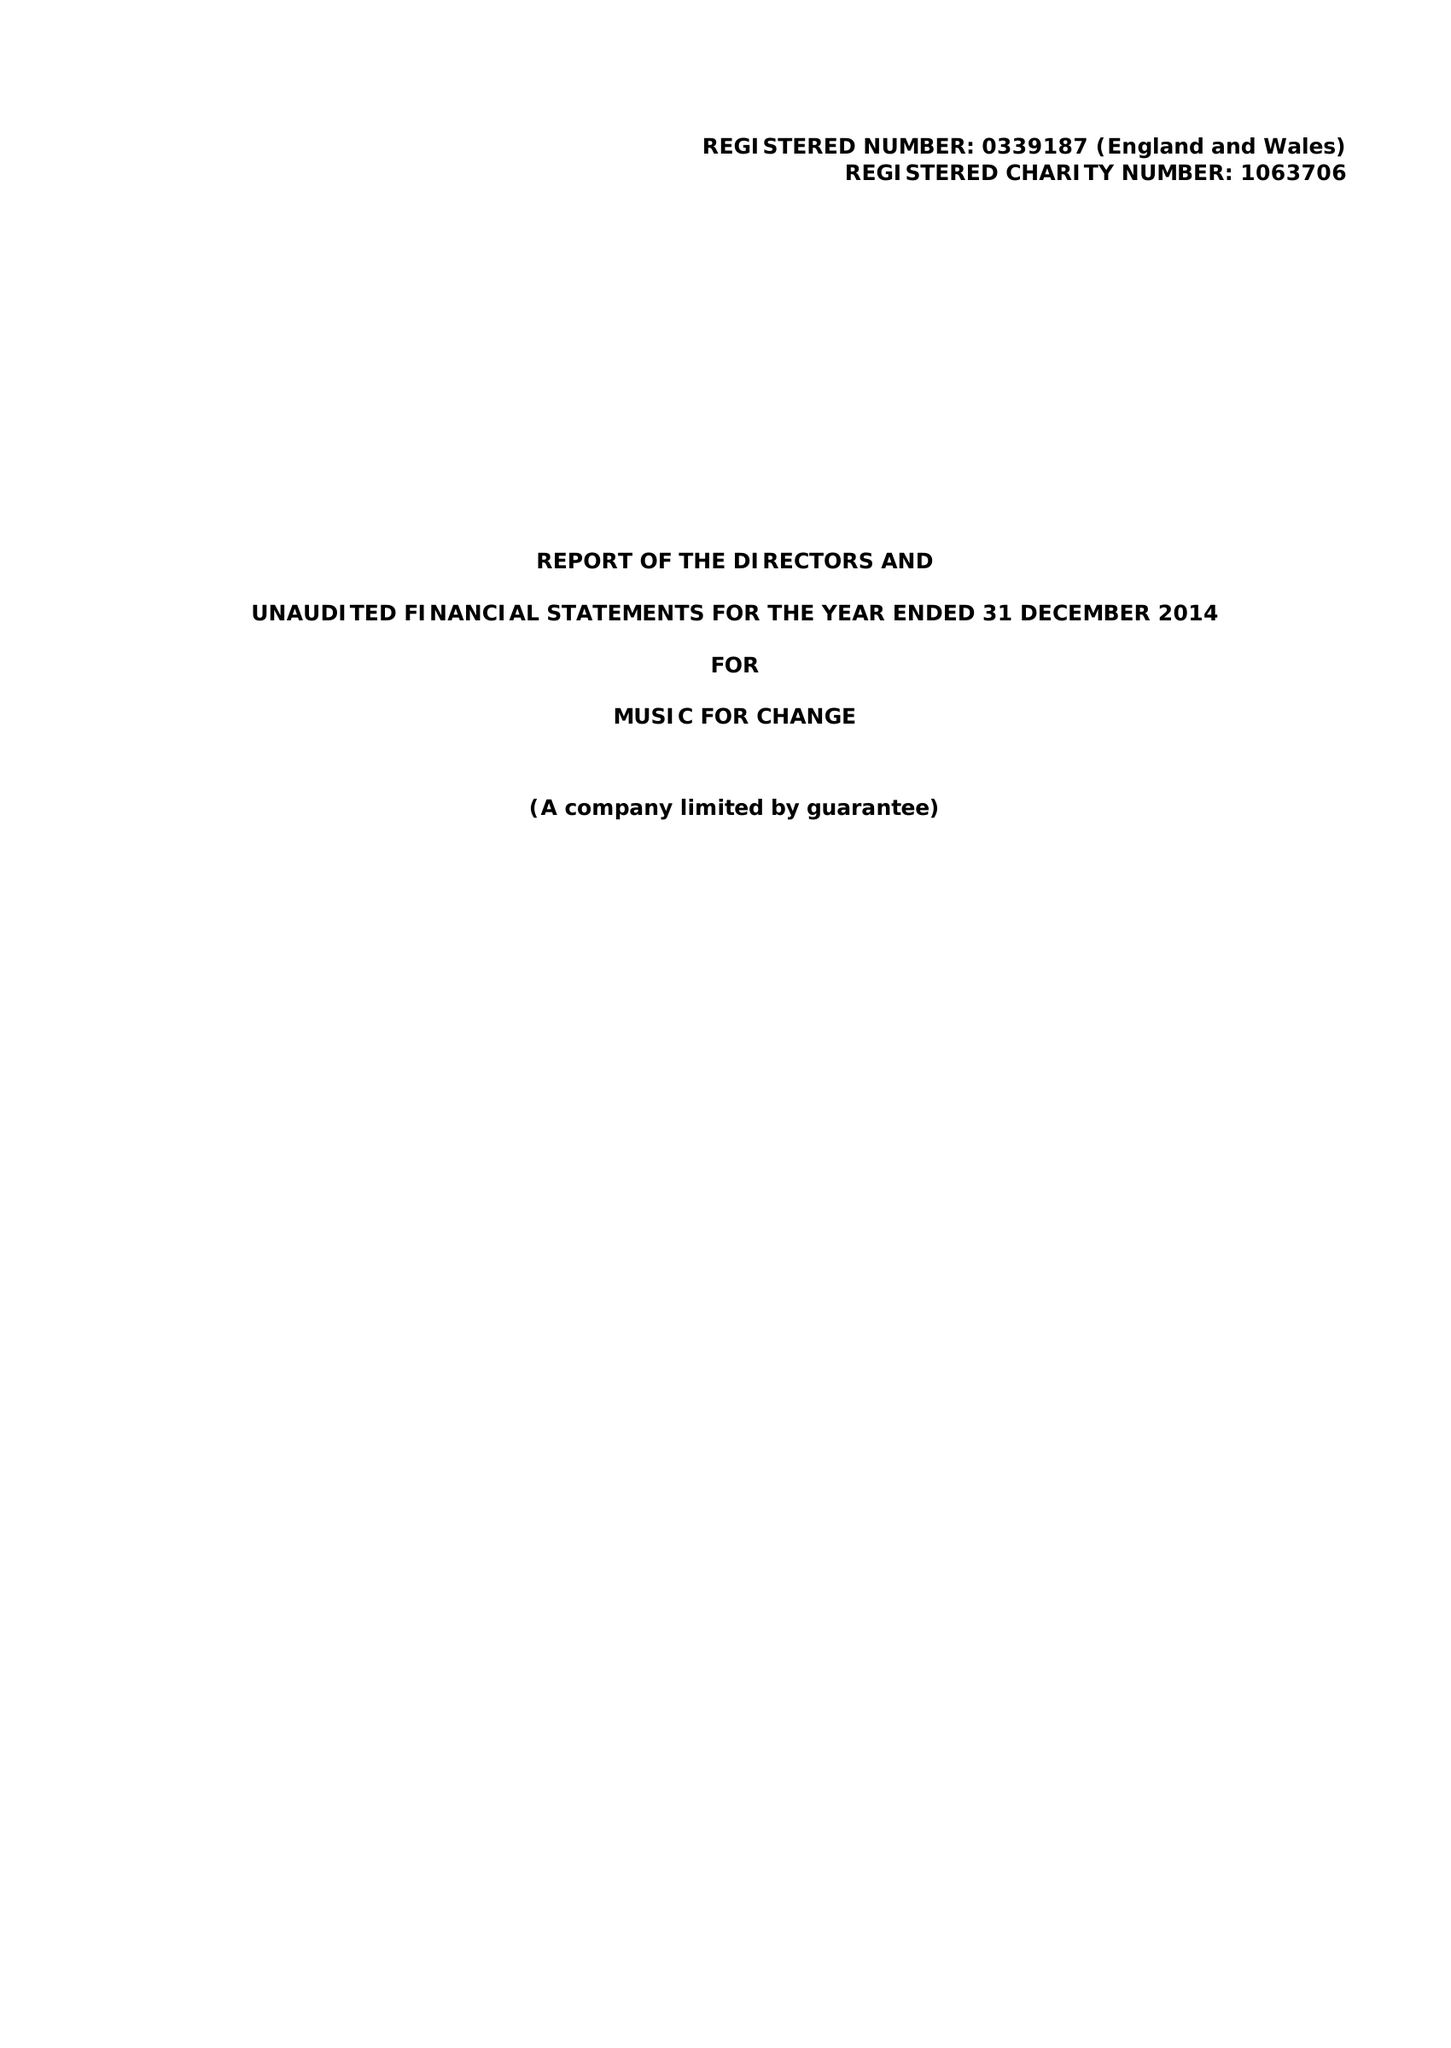What is the value for the spending_annually_in_british_pounds?
Answer the question using a single word or phrase. 127292.00 